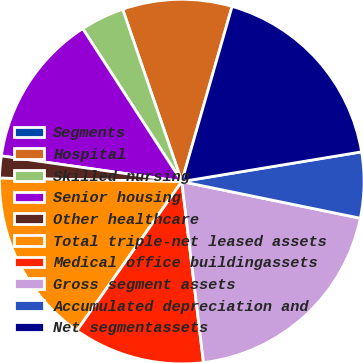<chart> <loc_0><loc_0><loc_500><loc_500><pie_chart><fcel>Segments<fcel>Hospital<fcel>Skilled nursing<fcel>Senior housing<fcel>Other healthcare<fcel>Total triple-net leased assets<fcel>Medical office buildingassets<fcel>Gross segment assets<fcel>Accumulated depreciation and<fcel>Net segmentassets<nl><fcel>0.0%<fcel>9.71%<fcel>3.89%<fcel>13.6%<fcel>1.95%<fcel>15.54%<fcel>11.66%<fcel>19.88%<fcel>5.83%<fcel>17.94%<nl></chart> 